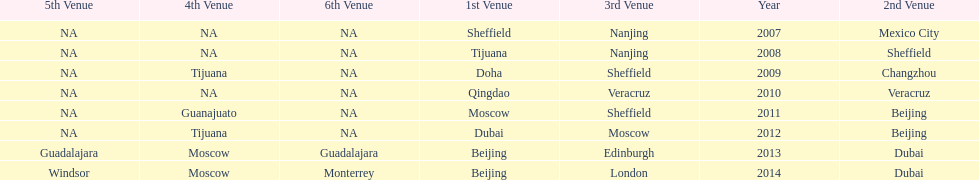What was the last year where tijuana was a venue? 2012. 